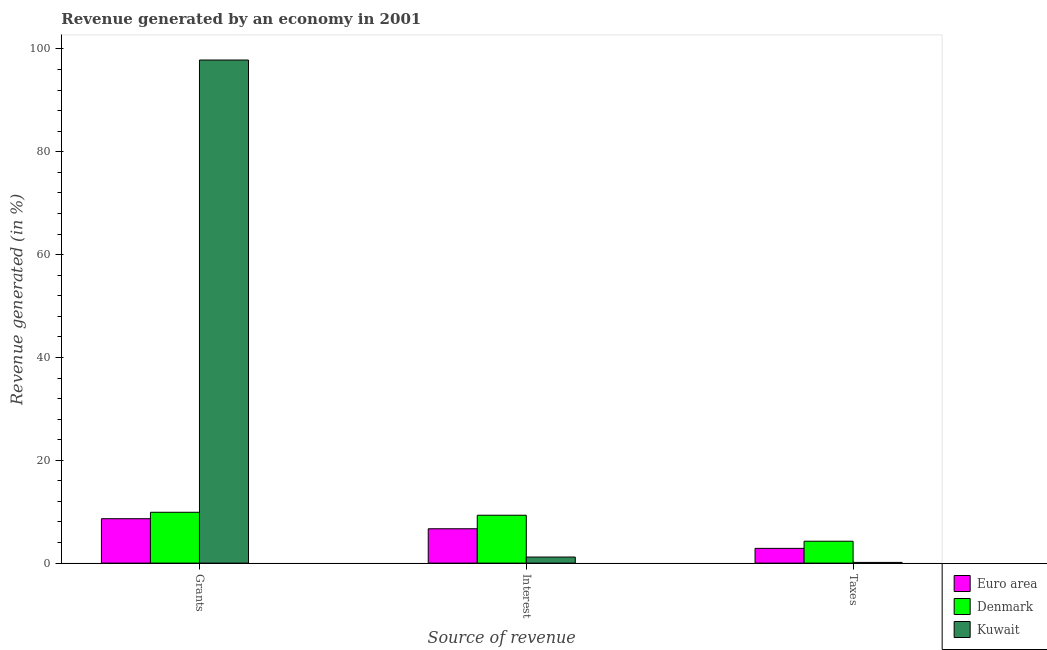How many groups of bars are there?
Make the answer very short. 3. Are the number of bars per tick equal to the number of legend labels?
Your response must be concise. Yes. Are the number of bars on each tick of the X-axis equal?
Provide a succinct answer. Yes. How many bars are there on the 3rd tick from the left?
Provide a short and direct response. 3. How many bars are there on the 3rd tick from the right?
Make the answer very short. 3. What is the label of the 2nd group of bars from the left?
Provide a succinct answer. Interest. What is the percentage of revenue generated by taxes in Kuwait?
Ensure brevity in your answer.  0.14. Across all countries, what is the maximum percentage of revenue generated by taxes?
Your answer should be compact. 4.26. Across all countries, what is the minimum percentage of revenue generated by taxes?
Provide a succinct answer. 0.14. In which country was the percentage of revenue generated by grants maximum?
Provide a succinct answer. Kuwait. In which country was the percentage of revenue generated by taxes minimum?
Offer a very short reply. Kuwait. What is the total percentage of revenue generated by taxes in the graph?
Your answer should be very brief. 7.26. What is the difference between the percentage of revenue generated by taxes in Denmark and that in Euro area?
Ensure brevity in your answer.  1.39. What is the difference between the percentage of revenue generated by interest in Euro area and the percentage of revenue generated by grants in Denmark?
Give a very brief answer. -3.21. What is the average percentage of revenue generated by interest per country?
Ensure brevity in your answer.  5.73. What is the difference between the percentage of revenue generated by interest and percentage of revenue generated by grants in Kuwait?
Provide a succinct answer. -96.67. In how many countries, is the percentage of revenue generated by grants greater than 60 %?
Your response must be concise. 1. What is the ratio of the percentage of revenue generated by grants in Kuwait to that in Denmark?
Your answer should be compact. 9.89. Is the percentage of revenue generated by interest in Kuwait less than that in Denmark?
Provide a succinct answer. Yes. What is the difference between the highest and the second highest percentage of revenue generated by grants?
Your answer should be very brief. 87.96. What is the difference between the highest and the lowest percentage of revenue generated by interest?
Provide a short and direct response. 8.13. In how many countries, is the percentage of revenue generated by interest greater than the average percentage of revenue generated by interest taken over all countries?
Provide a short and direct response. 2. Is the sum of the percentage of revenue generated by taxes in Kuwait and Denmark greater than the maximum percentage of revenue generated by grants across all countries?
Make the answer very short. No. What does the 3rd bar from the left in Grants represents?
Your response must be concise. Kuwait. What does the 1st bar from the right in Interest represents?
Ensure brevity in your answer.  Kuwait. Are all the bars in the graph horizontal?
Your response must be concise. No. How many countries are there in the graph?
Provide a succinct answer. 3. Are the values on the major ticks of Y-axis written in scientific E-notation?
Offer a terse response. No. Does the graph contain any zero values?
Make the answer very short. No. Does the graph contain grids?
Provide a short and direct response. No. Where does the legend appear in the graph?
Provide a succinct answer. Bottom right. How many legend labels are there?
Your answer should be compact. 3. How are the legend labels stacked?
Keep it short and to the point. Vertical. What is the title of the graph?
Ensure brevity in your answer.  Revenue generated by an economy in 2001. What is the label or title of the X-axis?
Provide a succinct answer. Source of revenue. What is the label or title of the Y-axis?
Provide a short and direct response. Revenue generated (in %). What is the Revenue generated (in %) in Euro area in Grants?
Offer a very short reply. 8.64. What is the Revenue generated (in %) in Denmark in Grants?
Keep it short and to the point. 9.89. What is the Revenue generated (in %) of Kuwait in Grants?
Offer a terse response. 97.85. What is the Revenue generated (in %) of Euro area in Interest?
Give a very brief answer. 6.68. What is the Revenue generated (in %) in Denmark in Interest?
Offer a very short reply. 9.32. What is the Revenue generated (in %) in Kuwait in Interest?
Provide a succinct answer. 1.18. What is the Revenue generated (in %) of Euro area in Taxes?
Your answer should be compact. 2.87. What is the Revenue generated (in %) in Denmark in Taxes?
Offer a very short reply. 4.26. What is the Revenue generated (in %) in Kuwait in Taxes?
Ensure brevity in your answer.  0.14. Across all Source of revenue, what is the maximum Revenue generated (in %) of Euro area?
Offer a very short reply. 8.64. Across all Source of revenue, what is the maximum Revenue generated (in %) in Denmark?
Make the answer very short. 9.89. Across all Source of revenue, what is the maximum Revenue generated (in %) in Kuwait?
Give a very brief answer. 97.85. Across all Source of revenue, what is the minimum Revenue generated (in %) in Euro area?
Give a very brief answer. 2.87. Across all Source of revenue, what is the minimum Revenue generated (in %) in Denmark?
Your answer should be very brief. 4.26. Across all Source of revenue, what is the minimum Revenue generated (in %) in Kuwait?
Give a very brief answer. 0.14. What is the total Revenue generated (in %) in Euro area in the graph?
Provide a succinct answer. 18.19. What is the total Revenue generated (in %) of Denmark in the graph?
Ensure brevity in your answer.  23.46. What is the total Revenue generated (in %) of Kuwait in the graph?
Keep it short and to the point. 99.17. What is the difference between the Revenue generated (in %) of Euro area in Grants and that in Interest?
Your answer should be very brief. 1.96. What is the difference between the Revenue generated (in %) of Denmark in Grants and that in Interest?
Provide a succinct answer. 0.57. What is the difference between the Revenue generated (in %) in Kuwait in Grants and that in Interest?
Provide a succinct answer. 96.67. What is the difference between the Revenue generated (in %) in Euro area in Grants and that in Taxes?
Keep it short and to the point. 5.77. What is the difference between the Revenue generated (in %) of Denmark in Grants and that in Taxes?
Your answer should be very brief. 5.63. What is the difference between the Revenue generated (in %) in Kuwait in Grants and that in Taxes?
Your answer should be very brief. 97.71. What is the difference between the Revenue generated (in %) of Euro area in Interest and that in Taxes?
Your answer should be very brief. 3.81. What is the difference between the Revenue generated (in %) of Denmark in Interest and that in Taxes?
Your answer should be compact. 5.06. What is the difference between the Revenue generated (in %) of Kuwait in Interest and that in Taxes?
Give a very brief answer. 1.05. What is the difference between the Revenue generated (in %) of Euro area in Grants and the Revenue generated (in %) of Denmark in Interest?
Provide a short and direct response. -0.68. What is the difference between the Revenue generated (in %) of Euro area in Grants and the Revenue generated (in %) of Kuwait in Interest?
Provide a succinct answer. 7.46. What is the difference between the Revenue generated (in %) in Denmark in Grants and the Revenue generated (in %) in Kuwait in Interest?
Provide a succinct answer. 8.71. What is the difference between the Revenue generated (in %) of Euro area in Grants and the Revenue generated (in %) of Denmark in Taxes?
Give a very brief answer. 4.38. What is the difference between the Revenue generated (in %) of Euro area in Grants and the Revenue generated (in %) of Kuwait in Taxes?
Provide a succinct answer. 8.5. What is the difference between the Revenue generated (in %) of Denmark in Grants and the Revenue generated (in %) of Kuwait in Taxes?
Make the answer very short. 9.75. What is the difference between the Revenue generated (in %) in Euro area in Interest and the Revenue generated (in %) in Denmark in Taxes?
Keep it short and to the point. 2.43. What is the difference between the Revenue generated (in %) of Euro area in Interest and the Revenue generated (in %) of Kuwait in Taxes?
Give a very brief answer. 6.55. What is the difference between the Revenue generated (in %) of Denmark in Interest and the Revenue generated (in %) of Kuwait in Taxes?
Provide a short and direct response. 9.18. What is the average Revenue generated (in %) in Euro area per Source of revenue?
Provide a succinct answer. 6.06. What is the average Revenue generated (in %) of Denmark per Source of revenue?
Provide a short and direct response. 7.82. What is the average Revenue generated (in %) in Kuwait per Source of revenue?
Give a very brief answer. 33.06. What is the difference between the Revenue generated (in %) of Euro area and Revenue generated (in %) of Denmark in Grants?
Keep it short and to the point. -1.25. What is the difference between the Revenue generated (in %) of Euro area and Revenue generated (in %) of Kuwait in Grants?
Give a very brief answer. -89.21. What is the difference between the Revenue generated (in %) of Denmark and Revenue generated (in %) of Kuwait in Grants?
Offer a terse response. -87.96. What is the difference between the Revenue generated (in %) in Euro area and Revenue generated (in %) in Denmark in Interest?
Make the answer very short. -2.63. What is the difference between the Revenue generated (in %) of Euro area and Revenue generated (in %) of Kuwait in Interest?
Offer a terse response. 5.5. What is the difference between the Revenue generated (in %) of Denmark and Revenue generated (in %) of Kuwait in Interest?
Offer a very short reply. 8.13. What is the difference between the Revenue generated (in %) of Euro area and Revenue generated (in %) of Denmark in Taxes?
Your answer should be compact. -1.39. What is the difference between the Revenue generated (in %) in Euro area and Revenue generated (in %) in Kuwait in Taxes?
Your answer should be compact. 2.73. What is the difference between the Revenue generated (in %) of Denmark and Revenue generated (in %) of Kuwait in Taxes?
Provide a succinct answer. 4.12. What is the ratio of the Revenue generated (in %) in Euro area in Grants to that in Interest?
Make the answer very short. 1.29. What is the ratio of the Revenue generated (in %) of Denmark in Grants to that in Interest?
Offer a terse response. 1.06. What is the ratio of the Revenue generated (in %) of Kuwait in Grants to that in Interest?
Your answer should be very brief. 82.84. What is the ratio of the Revenue generated (in %) of Euro area in Grants to that in Taxes?
Provide a short and direct response. 3.01. What is the ratio of the Revenue generated (in %) in Denmark in Grants to that in Taxes?
Your answer should be very brief. 2.32. What is the ratio of the Revenue generated (in %) of Kuwait in Grants to that in Taxes?
Provide a succinct answer. 721.86. What is the ratio of the Revenue generated (in %) in Euro area in Interest to that in Taxes?
Make the answer very short. 2.33. What is the ratio of the Revenue generated (in %) in Denmark in Interest to that in Taxes?
Make the answer very short. 2.19. What is the ratio of the Revenue generated (in %) in Kuwait in Interest to that in Taxes?
Make the answer very short. 8.71. What is the difference between the highest and the second highest Revenue generated (in %) of Euro area?
Keep it short and to the point. 1.96. What is the difference between the highest and the second highest Revenue generated (in %) in Denmark?
Provide a succinct answer. 0.57. What is the difference between the highest and the second highest Revenue generated (in %) in Kuwait?
Your answer should be compact. 96.67. What is the difference between the highest and the lowest Revenue generated (in %) of Euro area?
Your answer should be very brief. 5.77. What is the difference between the highest and the lowest Revenue generated (in %) of Denmark?
Your answer should be compact. 5.63. What is the difference between the highest and the lowest Revenue generated (in %) in Kuwait?
Offer a very short reply. 97.71. 